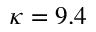<formula> <loc_0><loc_0><loc_500><loc_500>\kappa = 9 . 4</formula> 